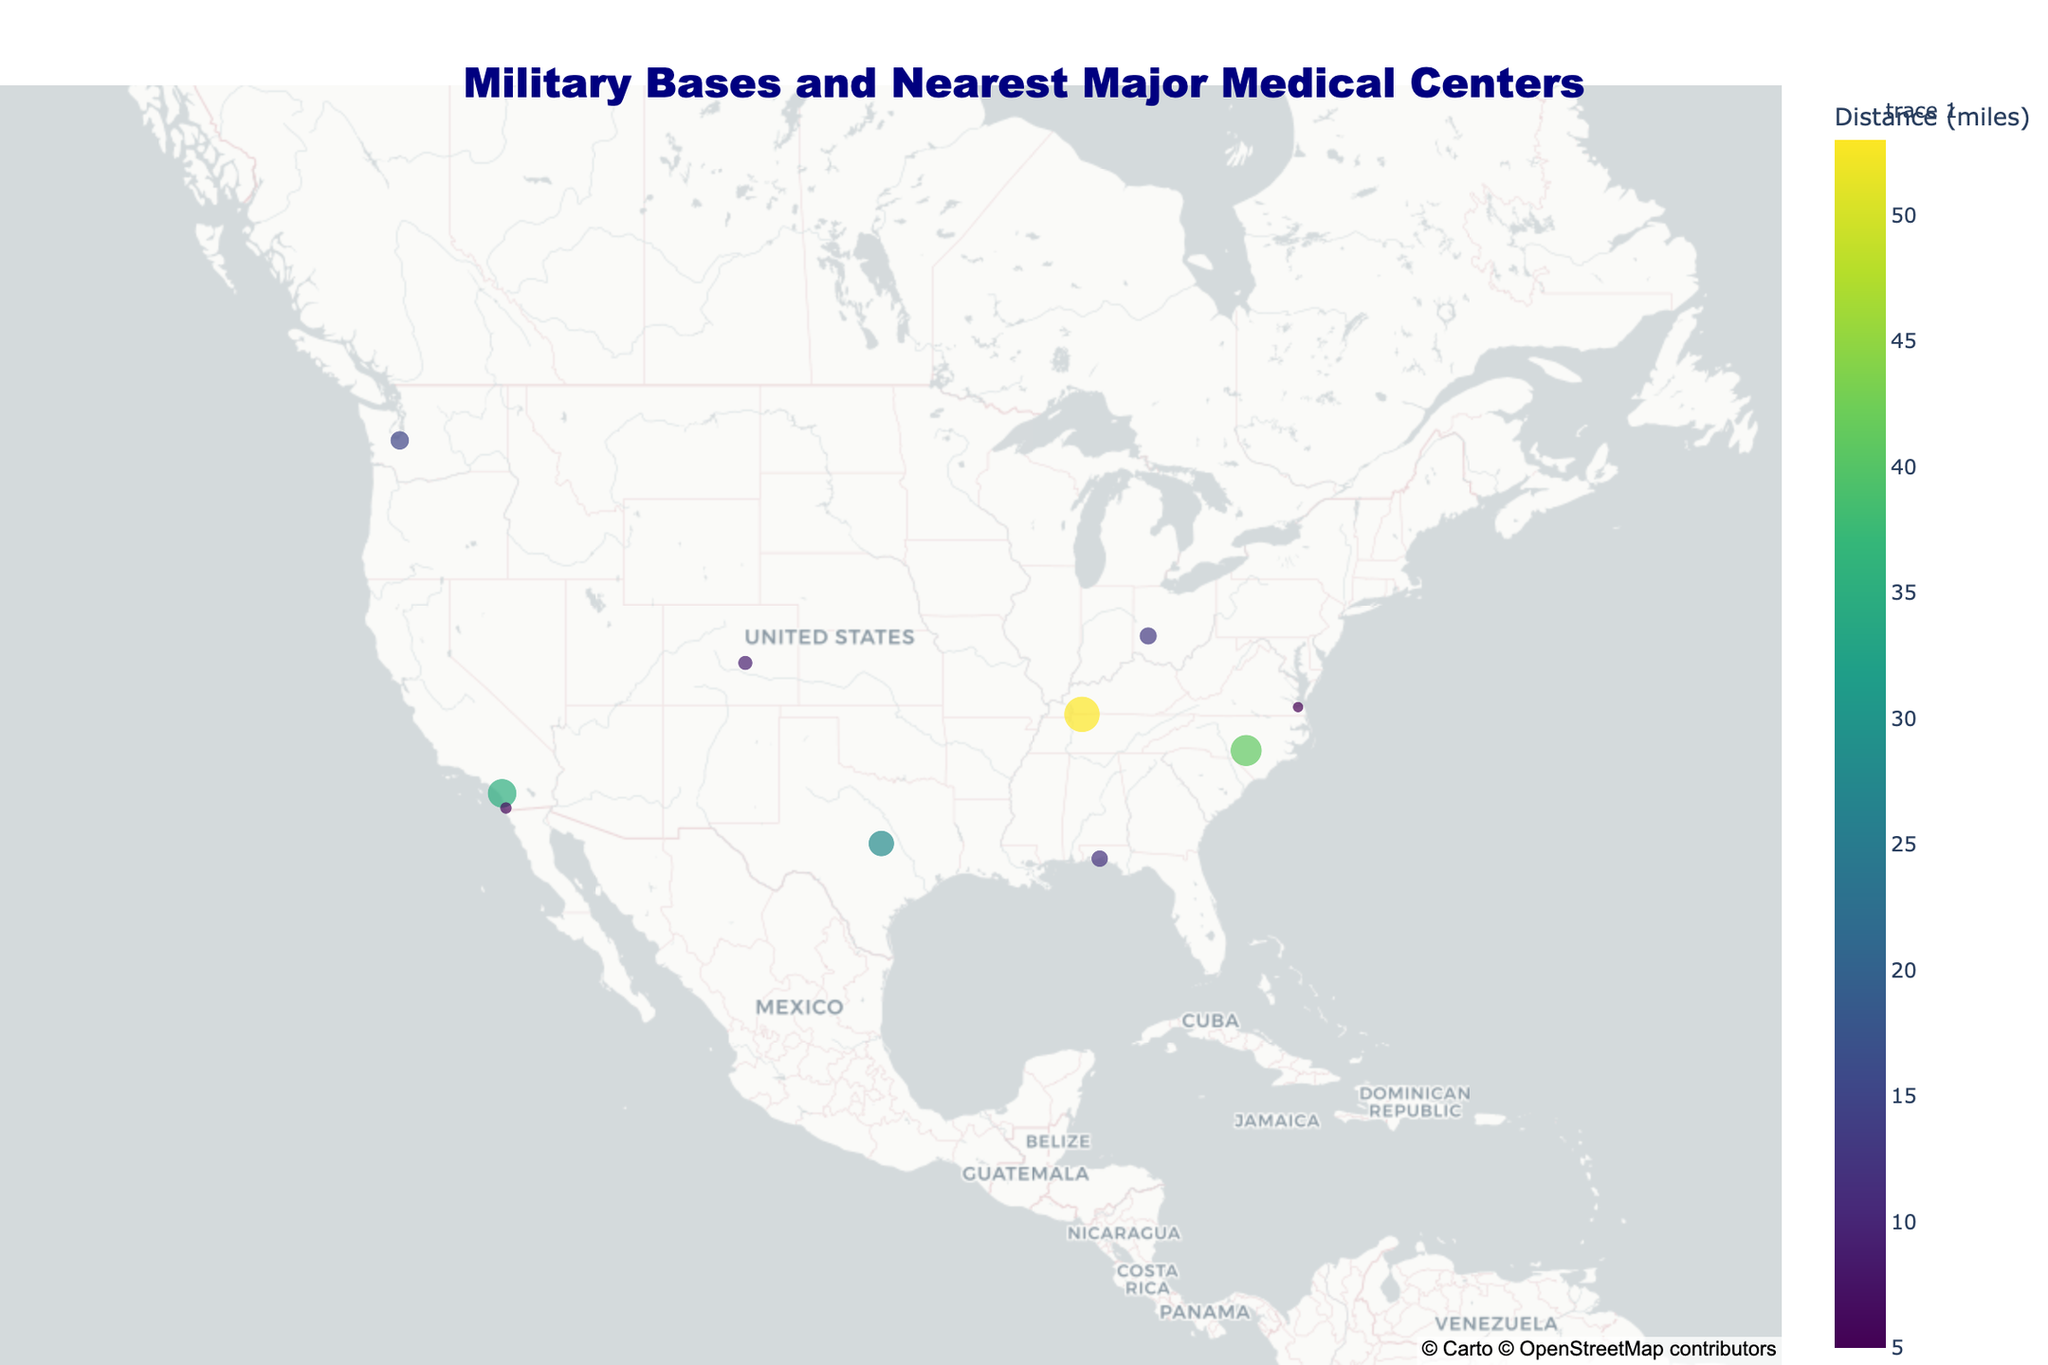How many military bases are shown in the figure? First, count the number of data points representing military bases. Each base is indicated by a red star marker.
Answer: 10 Which military base is the closest to its nearest major medical center? Look for the base with the smallest distance in miles. The size of the markers and the hover information can indicate this.
Answer: Naval Station Norfolk Which military base is the farthest from its nearest major medical center? Identify the base with the largest distance in miles. The size of the markers and the hover information are helpful.
Answer: Fort Campbell What's the average distance to major medical centers for all the military bases shown? Add up all the distances given in miles and divide by the number of military bases. (41 + 5 + 15 + 35 + 28 + 12 + 9 + 6 + 53 + 13) / 10 = 217 / 10
Answer: 21.7 Which two bases have the smallest and largest distances to their respective nearest major medical centers, and what are these distances? Use the hover data to find the minimum and maximum distances, then identify the bases associated with these values. Minimum: 5 miles (Naval Station Norfolk). Maximum: 53 miles (Fort Campbell).
Answer: Naval Station Norfolk (5 miles) and Fort Campbell (53 miles) What is the median distance of the military bases to their nearest major medical centers? Arrange all distances in ascending order and find the middle value. If there is an even number of bases, take the average of the two central numbers. Sorted distances: 5, 6, 9, 12, 13, 15, 28, 35, 41, 53. Median: (13 + 15) / 2
Answer: 14 How many military bases have a distance of less than 10 miles to their nearest major medical center? Identify and count the bases with distances below 10 miles by examining the hover data or the marker sizes.
Answer: 3 Which military bases are located on the West Coast of the United States? Locate bases with longitudes less than -120 (since the West Coast is generally defined by longitudes west of this line). These bases are Joint Base Lewis-McChord, Camp Pendleton, and Naval Base San Diego.
Answer: Joint Base Lewis-McChord, Camp Pendleton, Naval Base San Diego Which medical center serves the Fort Hood base, and what is the distance in miles? Find Fort Hood in the hover data and read the associated major medical center and distance information.
Answer: Baylor Scott & White Medical Center - Temple, 28 miles 